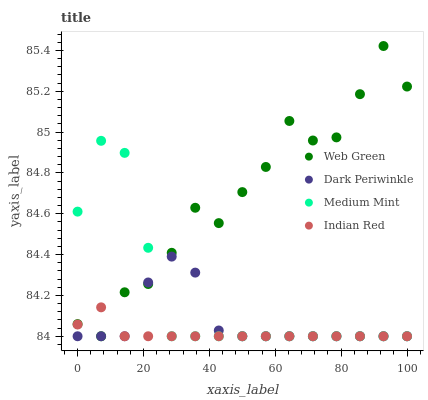Does Indian Red have the minimum area under the curve?
Answer yes or no. Yes. Does Web Green have the maximum area under the curve?
Answer yes or no. Yes. Does Dark Periwinkle have the minimum area under the curve?
Answer yes or no. No. Does Dark Periwinkle have the maximum area under the curve?
Answer yes or no. No. Is Indian Red the smoothest?
Answer yes or no. Yes. Is Web Green the roughest?
Answer yes or no. Yes. Is Dark Periwinkle the smoothest?
Answer yes or no. No. Is Dark Periwinkle the roughest?
Answer yes or no. No. Does Medium Mint have the lowest value?
Answer yes or no. Yes. Does Web Green have the highest value?
Answer yes or no. Yes. Does Dark Periwinkle have the highest value?
Answer yes or no. No. Does Dark Periwinkle intersect Indian Red?
Answer yes or no. Yes. Is Dark Periwinkle less than Indian Red?
Answer yes or no. No. Is Dark Periwinkle greater than Indian Red?
Answer yes or no. No. 